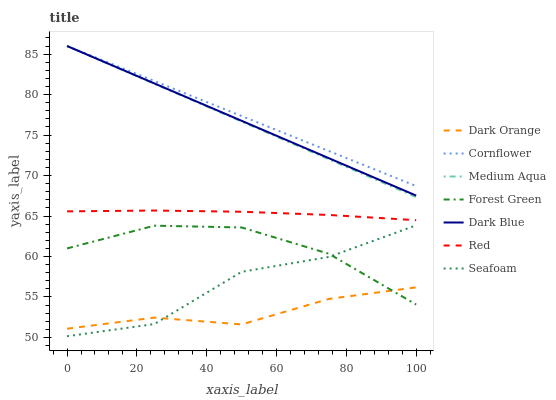Does Dark Orange have the minimum area under the curve?
Answer yes or no. Yes. Does Cornflower have the maximum area under the curve?
Answer yes or no. Yes. Does Seafoam have the minimum area under the curve?
Answer yes or no. No. Does Seafoam have the maximum area under the curve?
Answer yes or no. No. Is Dark Blue the smoothest?
Answer yes or no. Yes. Is Seafoam the roughest?
Answer yes or no. Yes. Is Cornflower the smoothest?
Answer yes or no. No. Is Cornflower the roughest?
Answer yes or no. No. Does Seafoam have the lowest value?
Answer yes or no. Yes. Does Cornflower have the lowest value?
Answer yes or no. No. Does Medium Aqua have the highest value?
Answer yes or no. Yes. Does Seafoam have the highest value?
Answer yes or no. No. Is Seafoam less than Dark Blue?
Answer yes or no. Yes. Is Cornflower greater than Forest Green?
Answer yes or no. Yes. Does Dark Blue intersect Medium Aqua?
Answer yes or no. Yes. Is Dark Blue less than Medium Aqua?
Answer yes or no. No. Is Dark Blue greater than Medium Aqua?
Answer yes or no. No. Does Seafoam intersect Dark Blue?
Answer yes or no. No. 